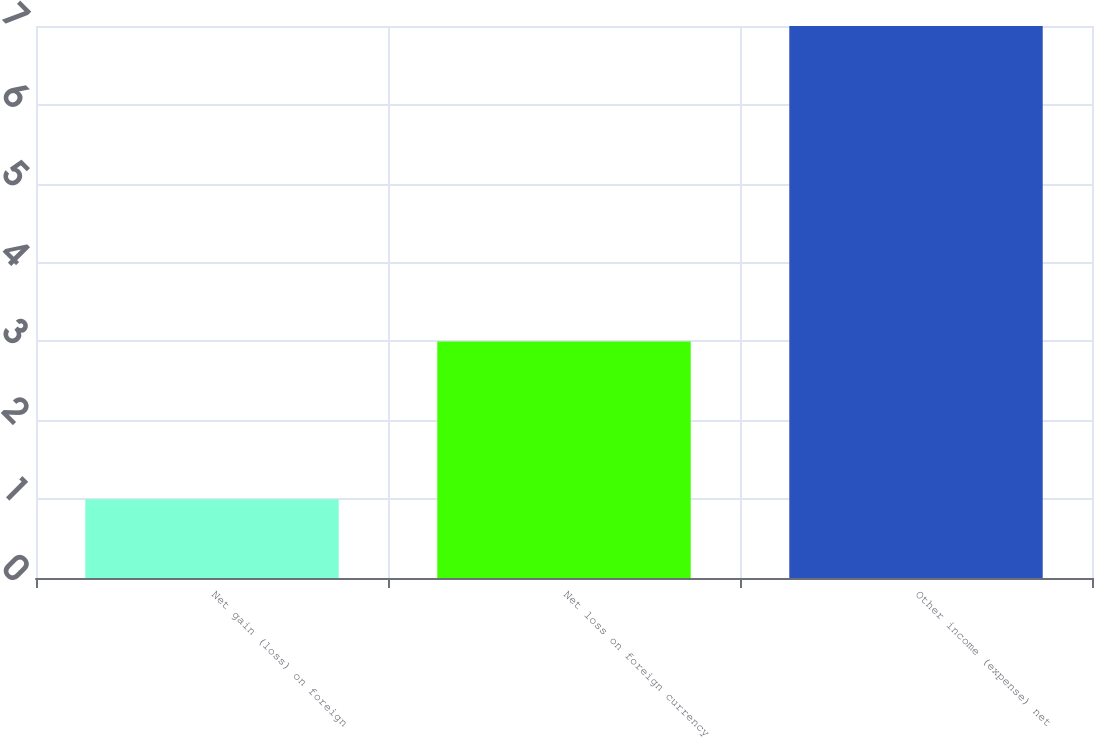Convert chart to OTSL. <chart><loc_0><loc_0><loc_500><loc_500><bar_chart><fcel>Net gain (loss) on foreign<fcel>Net loss on foreign currency<fcel>Other income (expense) net<nl><fcel>1<fcel>3<fcel>7<nl></chart> 